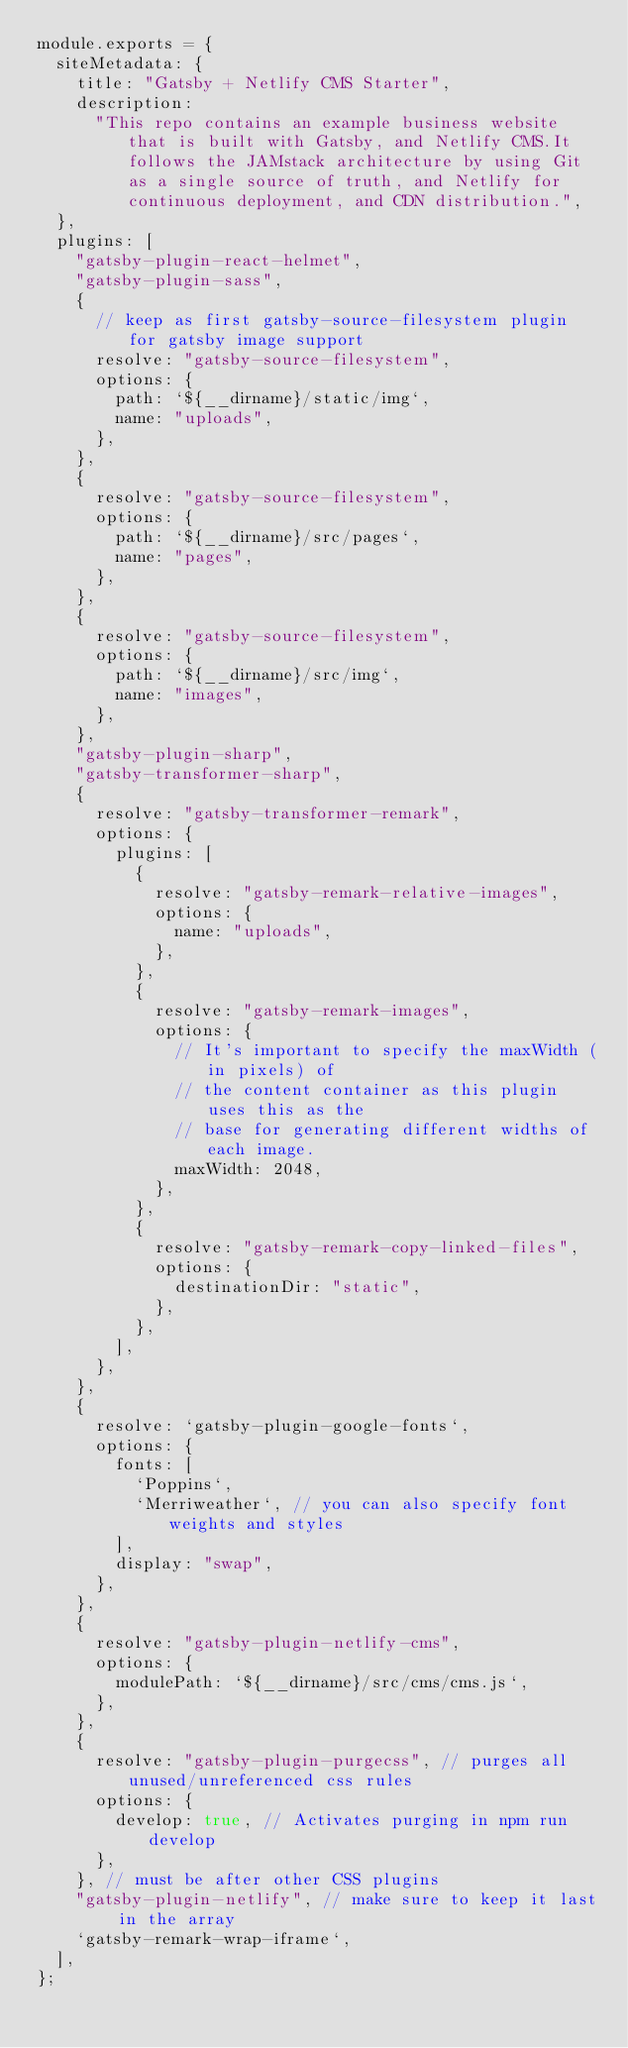<code> <loc_0><loc_0><loc_500><loc_500><_JavaScript_>module.exports = {
  siteMetadata: {
    title: "Gatsby + Netlify CMS Starter",
    description:
      "This repo contains an example business website that is built with Gatsby, and Netlify CMS.It follows the JAMstack architecture by using Git as a single source of truth, and Netlify for continuous deployment, and CDN distribution.",
  },
  plugins: [
    "gatsby-plugin-react-helmet",
    "gatsby-plugin-sass",
    {
      // keep as first gatsby-source-filesystem plugin for gatsby image support
      resolve: "gatsby-source-filesystem",
      options: {
        path: `${__dirname}/static/img`,
        name: "uploads",
      },
    },
    {
      resolve: "gatsby-source-filesystem",
      options: {
        path: `${__dirname}/src/pages`,
        name: "pages",
      },
    },
    {
      resolve: "gatsby-source-filesystem",
      options: {
        path: `${__dirname}/src/img`,
        name: "images",
      },
    },
    "gatsby-plugin-sharp",
    "gatsby-transformer-sharp",
    {
      resolve: "gatsby-transformer-remark",
      options: {
        plugins: [
          {
            resolve: "gatsby-remark-relative-images",
            options: {
              name: "uploads",
            },
          },
          {
            resolve: "gatsby-remark-images",
            options: {
              // It's important to specify the maxWidth (in pixels) of
              // the content container as this plugin uses this as the
              // base for generating different widths of each image.
              maxWidth: 2048,
            },
          },
          {
            resolve: "gatsby-remark-copy-linked-files",
            options: {
              destinationDir: "static",
            },
          },
        ],
      },
    },
    {
      resolve: `gatsby-plugin-google-fonts`,
      options: {
        fonts: [
          `Poppins`,
          `Merriweather`, // you can also specify font weights and styles
        ],
        display: "swap",
      },
    },
    {
      resolve: "gatsby-plugin-netlify-cms",
      options: {
        modulePath: `${__dirname}/src/cms/cms.js`,
      },
    },
    {
      resolve: "gatsby-plugin-purgecss", // purges all unused/unreferenced css rules
      options: {
        develop: true, // Activates purging in npm run develop
      },
    }, // must be after other CSS plugins
    "gatsby-plugin-netlify", // make sure to keep it last in the array
    `gatsby-remark-wrap-iframe`,
  ],
};
</code> 